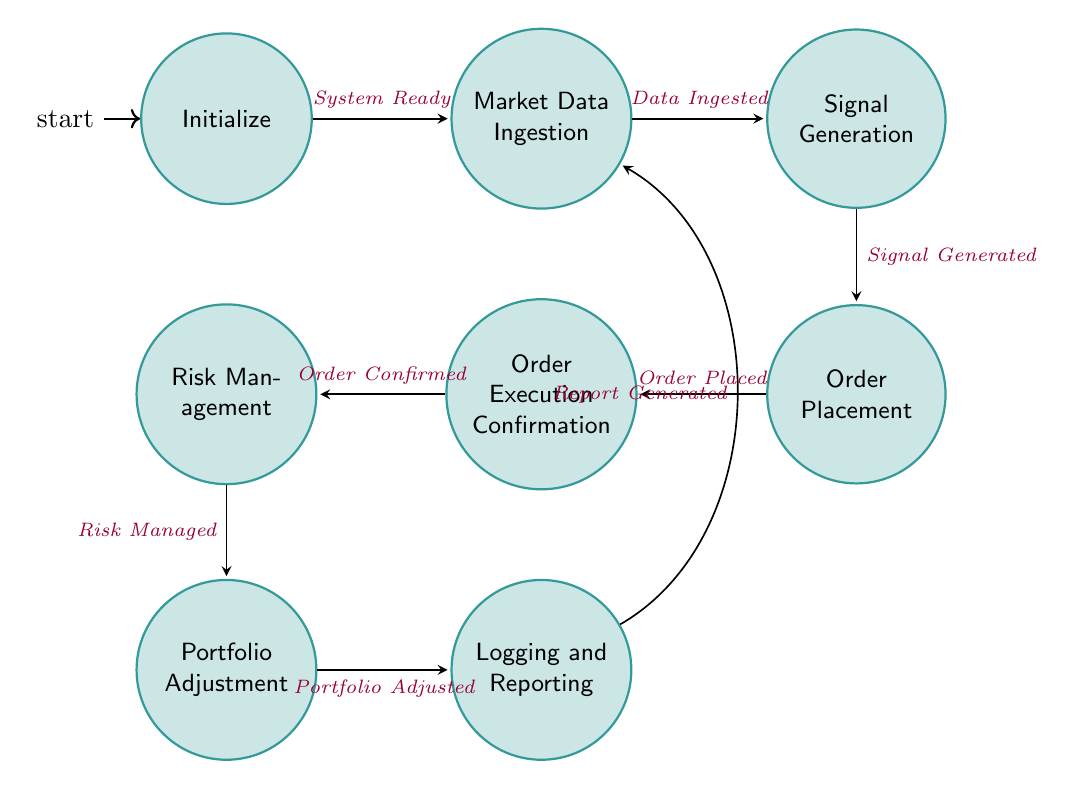What is the first state in the diagram? The first state is labeled as "Initialize", which is the starting point of the automated trading workflow. It is indicated as the initial state in the diagram.
Answer: Initialize How many nodes are there in total? To count the nodes, we simply look at each labeled state in the diagram. There are eight states: Initialize, Market Data Ingestion, Signal Generation, Order Placement, Order Execution Confirmation, Risk Management, Portfolio Adjustment, Logging and Reporting. Therefore, the total number of nodes is eight.
Answer: 8 What follows the "Signal Generation" state? The state that follows "Signal Generation" is "Order Placement". This transition is indicated by the arrow pointing from "Signal Generation" to "Order Placement".
Answer: Order Placement Which state requires risk management? The state that requires risk management is "Risk Management". It follows "Order Execution Confirmation" and is crucial for monitoring and managing risk in the workflow.
Answer: Risk Management What is the trigger for moving from "Order Placement" to "Order Execution Confirmation"? The transition from "Order Placement" to "Order Execution Confirmation" occurs with the trigger "Order Placed". This trigger is labeled on the arrow connecting the two states.
Answer: Order Placed If the report is generated, which state do we return to? After generating the report in the "Logging and Reporting" state, the workflow returns to the "Market Data Ingestion" state. The transition is labeled with "Report Generated", indicating the cyclical flow back to data ingestion.
Answer: Market Data Ingestion What is the last state in the workflow? The last state of the automated trading workflow is "Logging and Reporting". This is the final step in the sequence before the flow returns to data ingestion.
Answer: Logging and Reporting How many transitions are there in the diagram? To determine the number of transitions, we can count each arrow connecting two states in the diagram. There are a total of seven transitions shown in the connections between the eight states.
Answer: 7 What type of node is "Order Execution Confirmation"? "Order Execution Confirmation" is classified as a state node within the finite state machine. It acts as a checkpoint to confirm whether an order has been executed successfully.
Answer: state node 